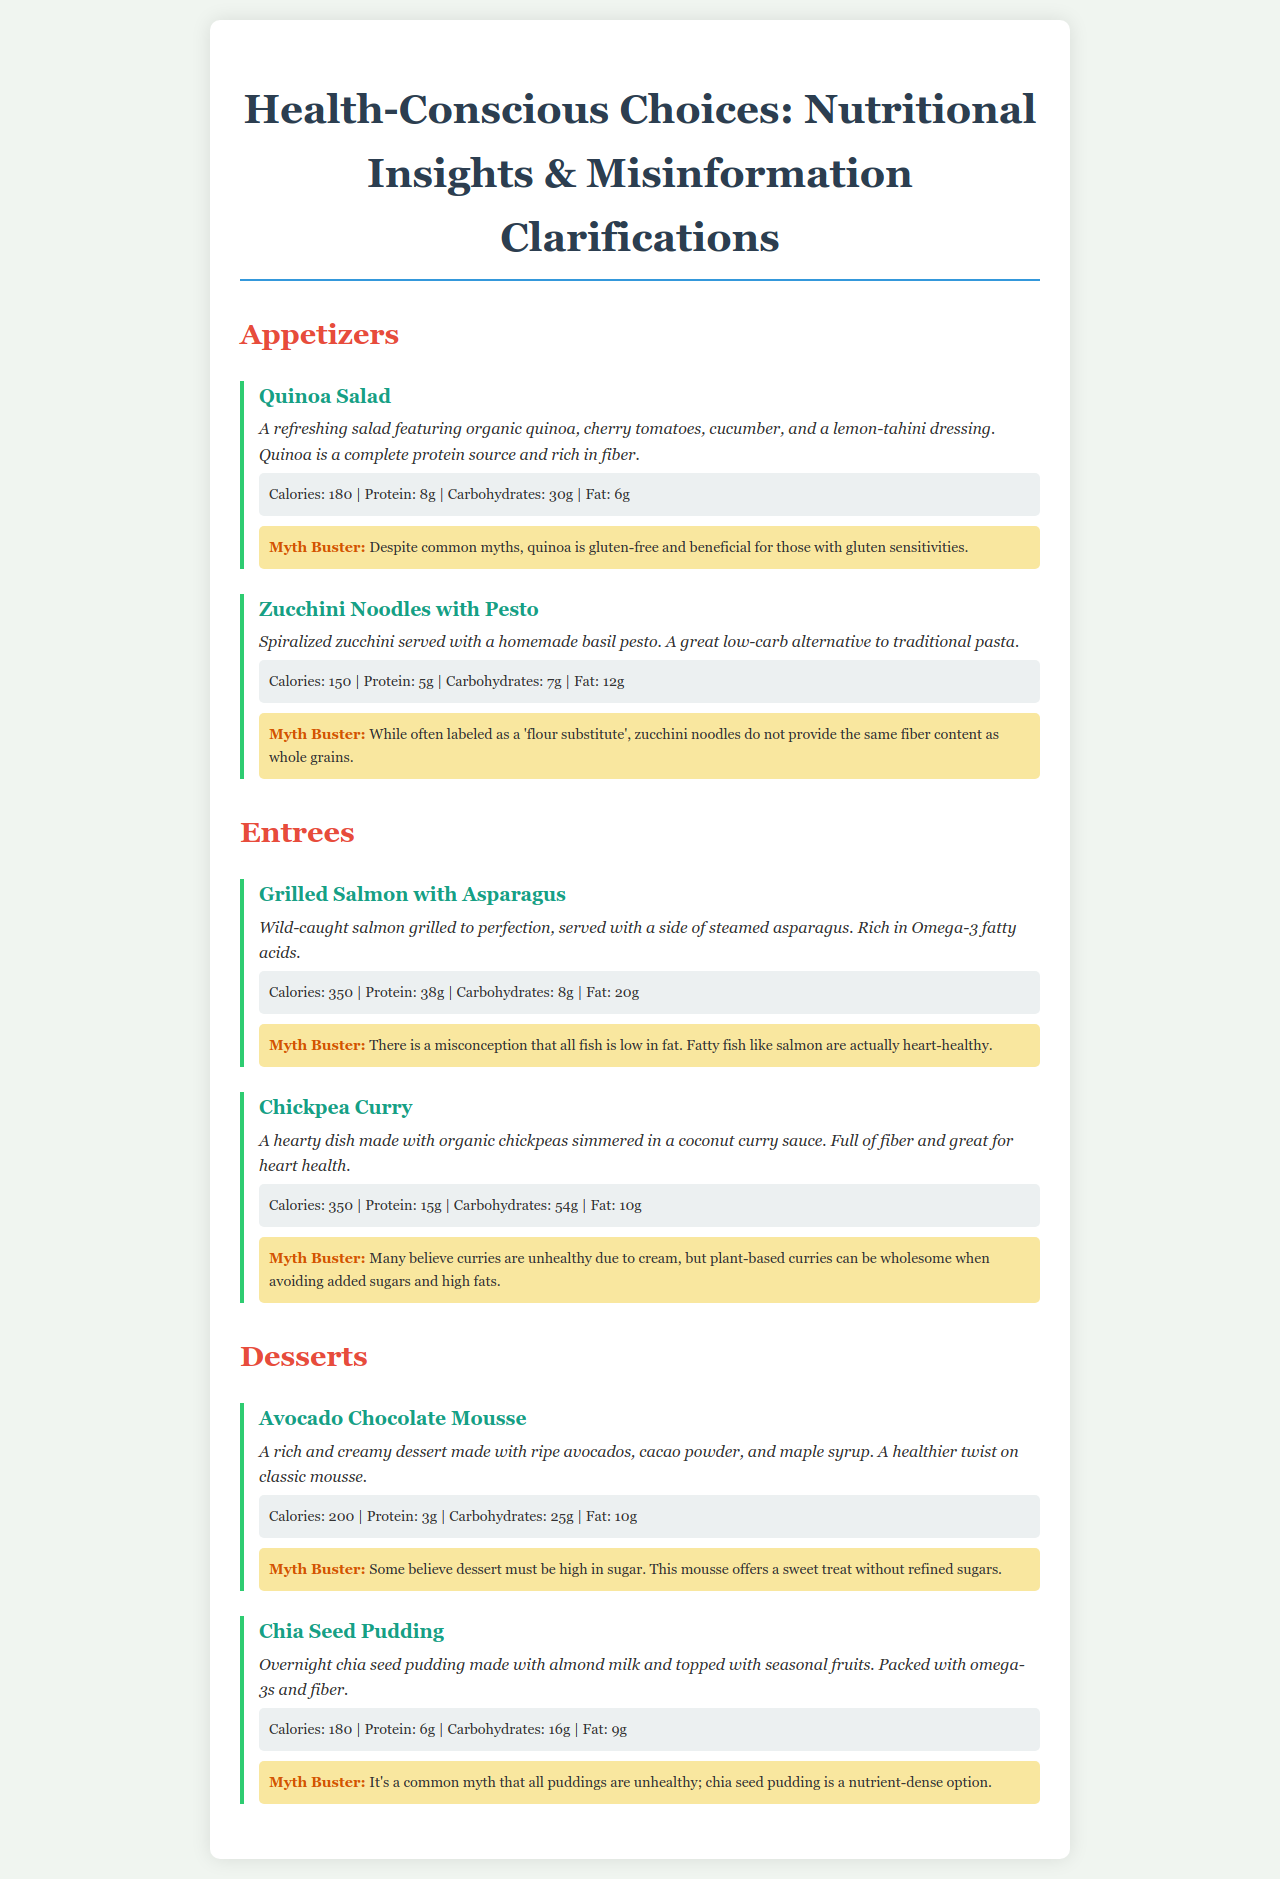What is the calorie count of the Quinoa Salad? The calorie count is listed in the nutrition information for the Quinoa Salad, which shows 180 calories.
Answer: 180 How many grams of protein are in the Grilled Salmon with Asparagus? The nutrition information for the Grilled Salmon with Asparagus indicates there are 38 grams of protein.
Answer: 38g What dressing is used in the Quinoa Salad? The description of the Quinoa Salad specifies that it is served with a lemon-tahini dressing.
Answer: lemon-tahini What is a common myth about quinoa? The clarification for the Quinoa Salad states that a common myth is that quinoa is not gluten-free.
Answer: gluten-free What is a misconception about the fat content of fish? The clarification for the Grilled Salmon with Asparagus mentions that there is a misconception that all fish is low in fat.
Answer: all fish is low in fat How does the calorie count of the Avocado Chocolate Mousse compare to the Chia Seed Pudding? The calorie count for the Avocado Chocolate Mousse is 200, while the Chia Seed Pudding is 180, indicating a comparison of 20 calories more in the mousse.
Answer: 20 calories more Which dessert is described as packed with omega-3s? The description in the menu highlights that the Chia Seed Pudding is packed with omega-3s and fiber.
Answer: Chia Seed Pudding How many grams of carbohydrates are in the Chickpea Curry? The nutrition information for the Chickpea Curry details that it contains 54 grams of carbohydrates.
Answer: 54g What is the main ingredient in the Zucchini Noodles with Pesto? The description indicates the main ingredient is spiralized zucchini.
Answer: spiralized zucchini 